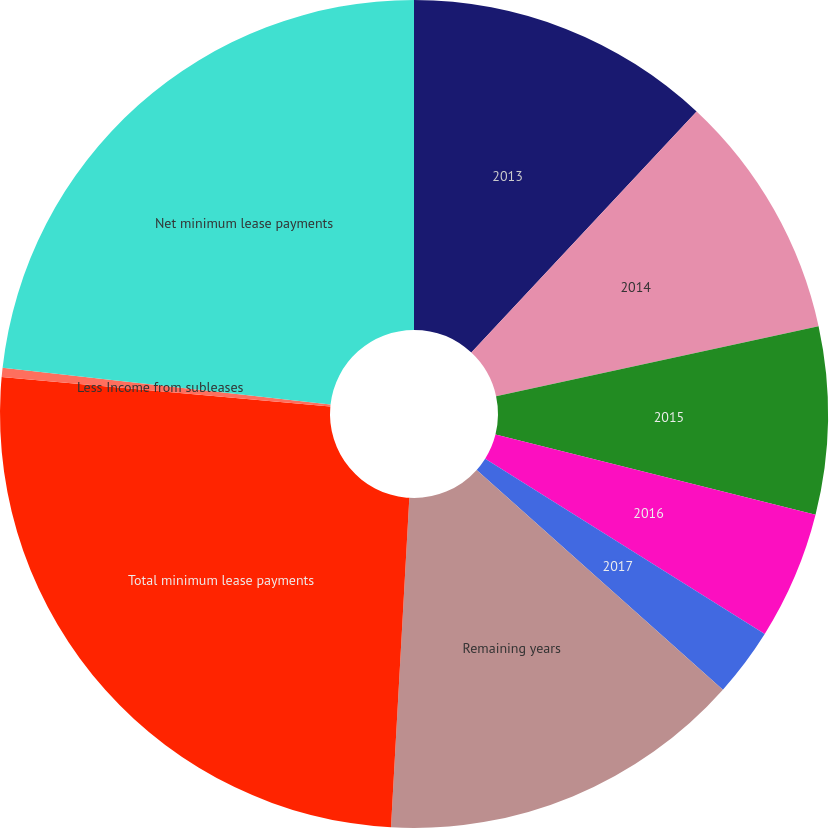Convert chart to OTSL. <chart><loc_0><loc_0><loc_500><loc_500><pie_chart><fcel>2013<fcel>2014<fcel>2015<fcel>2016<fcel>2017<fcel>Remaining years<fcel>Total minimum lease payments<fcel>Less Income from subleases<fcel>Net minimum lease payments<nl><fcel>11.96%<fcel>9.64%<fcel>7.32%<fcel>5.0%<fcel>2.68%<fcel>14.29%<fcel>25.54%<fcel>0.36%<fcel>23.22%<nl></chart> 